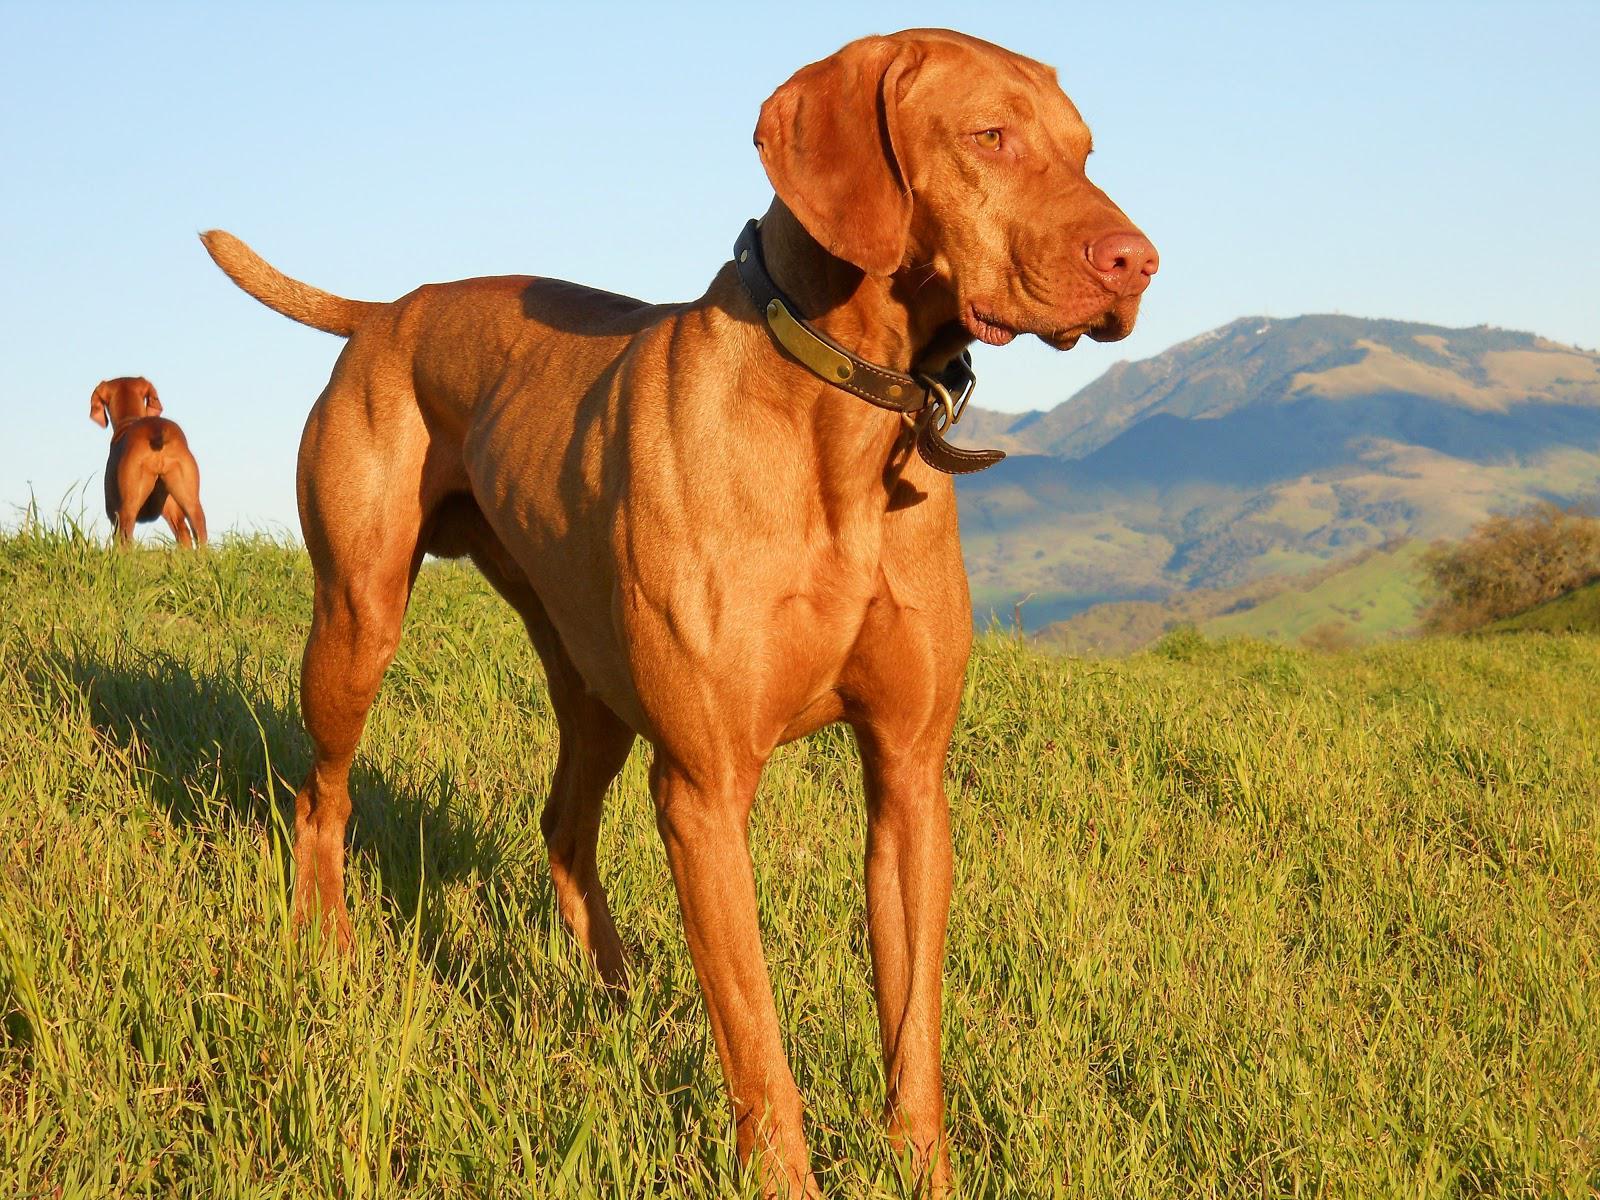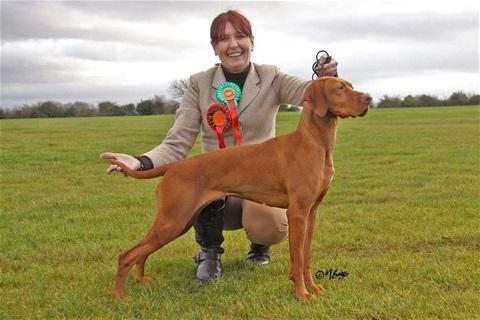The first image is the image on the left, the second image is the image on the right. Examine the images to the left and right. Is the description "In the right image, there's a single Vizsla facing the right." accurate? Answer yes or no. Yes. The first image is the image on the left, the second image is the image on the right. For the images displayed, is the sentence "There are at least four dogs in total." factually correct? Answer yes or no. No. 